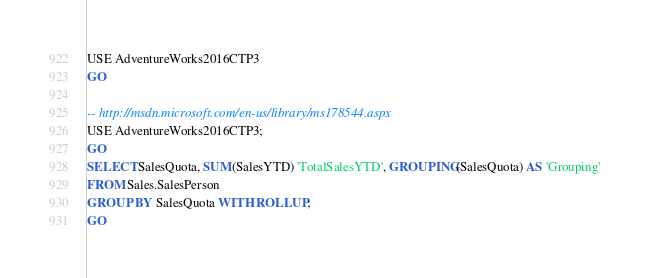Convert code to text. <code><loc_0><loc_0><loc_500><loc_500><_SQL_>USE AdventureWorks2016CTP3
GO

-- http://msdn.microsoft.com/en-us/library/ms178544.aspx
USE AdventureWorks2016CTP3;
GO
SELECT SalesQuota, SUM(SalesYTD) 'TotalSalesYTD', GROUPING(SalesQuota) AS 'Grouping'
FROM Sales.SalesPerson
GROUP BY SalesQuota WITH ROLLUP;
GO
</code> 